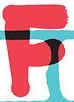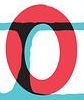What words are shown in these images in order, separated by a semicolon? F; O 